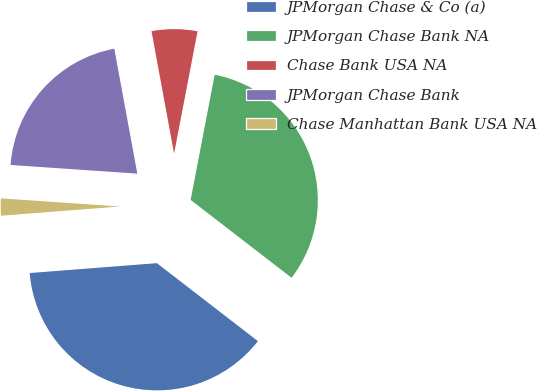<chart> <loc_0><loc_0><loc_500><loc_500><pie_chart><fcel>JPMorgan Chase & Co (a)<fcel>JPMorgan Chase Bank NA<fcel>Chase Bank USA NA<fcel>JPMorgan Chase Bank<fcel>Chase Manhattan Bank USA NA<nl><fcel>38.3%<fcel>32.44%<fcel>5.92%<fcel>21.01%<fcel>2.32%<nl></chart> 